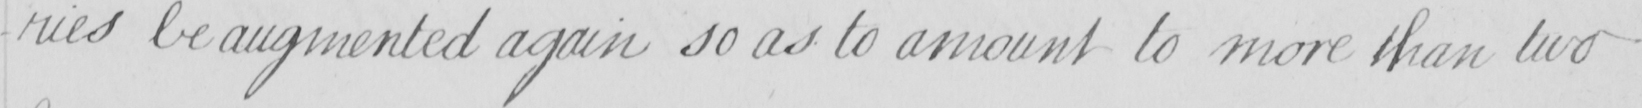What does this handwritten line say? -ries be augmented again so as to amount to more than two 